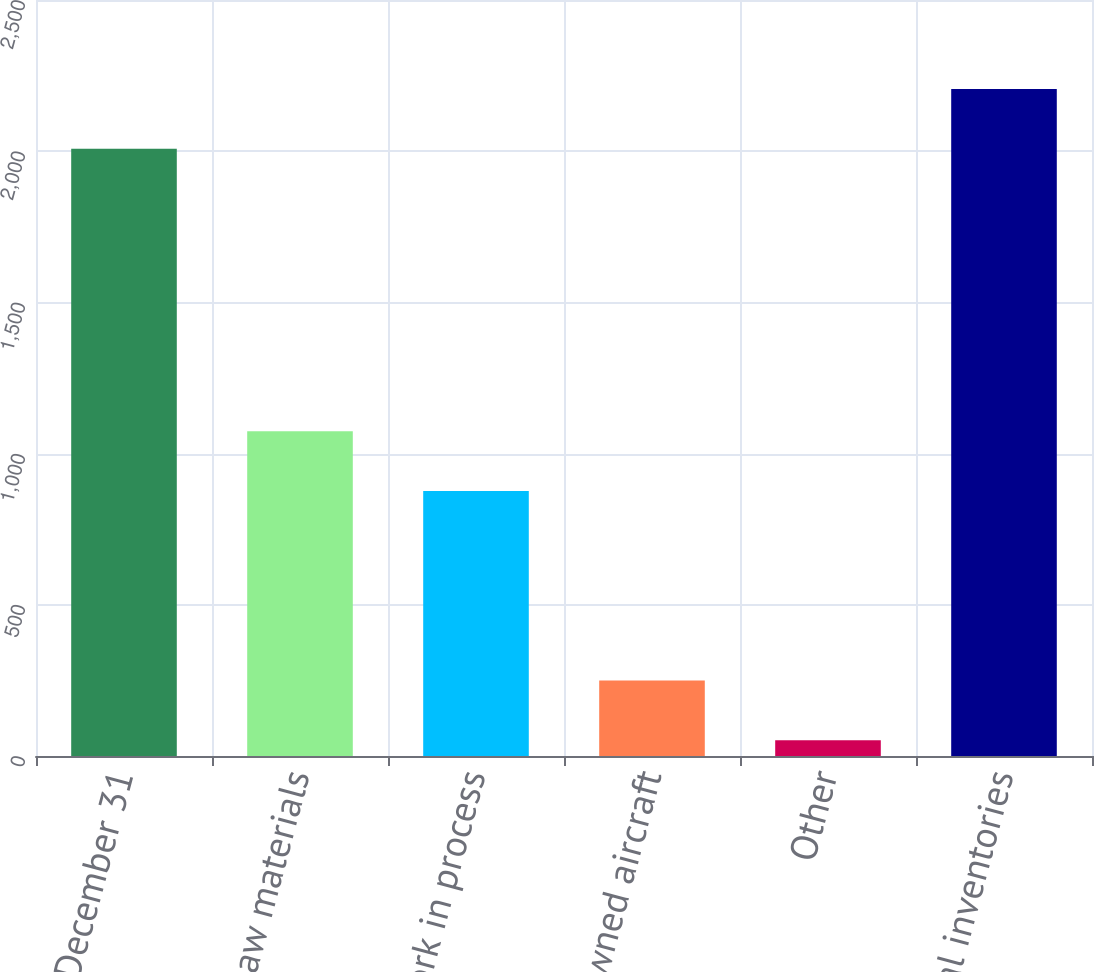Convert chart. <chart><loc_0><loc_0><loc_500><loc_500><bar_chart><fcel>December 31<fcel>Raw materials<fcel>Work in process<fcel>Pre - owned aircraft<fcel>Other<fcel>Total inventories<nl><fcel>2008<fcel>1073.7<fcel>876<fcel>249.7<fcel>52<fcel>2205.7<nl></chart> 